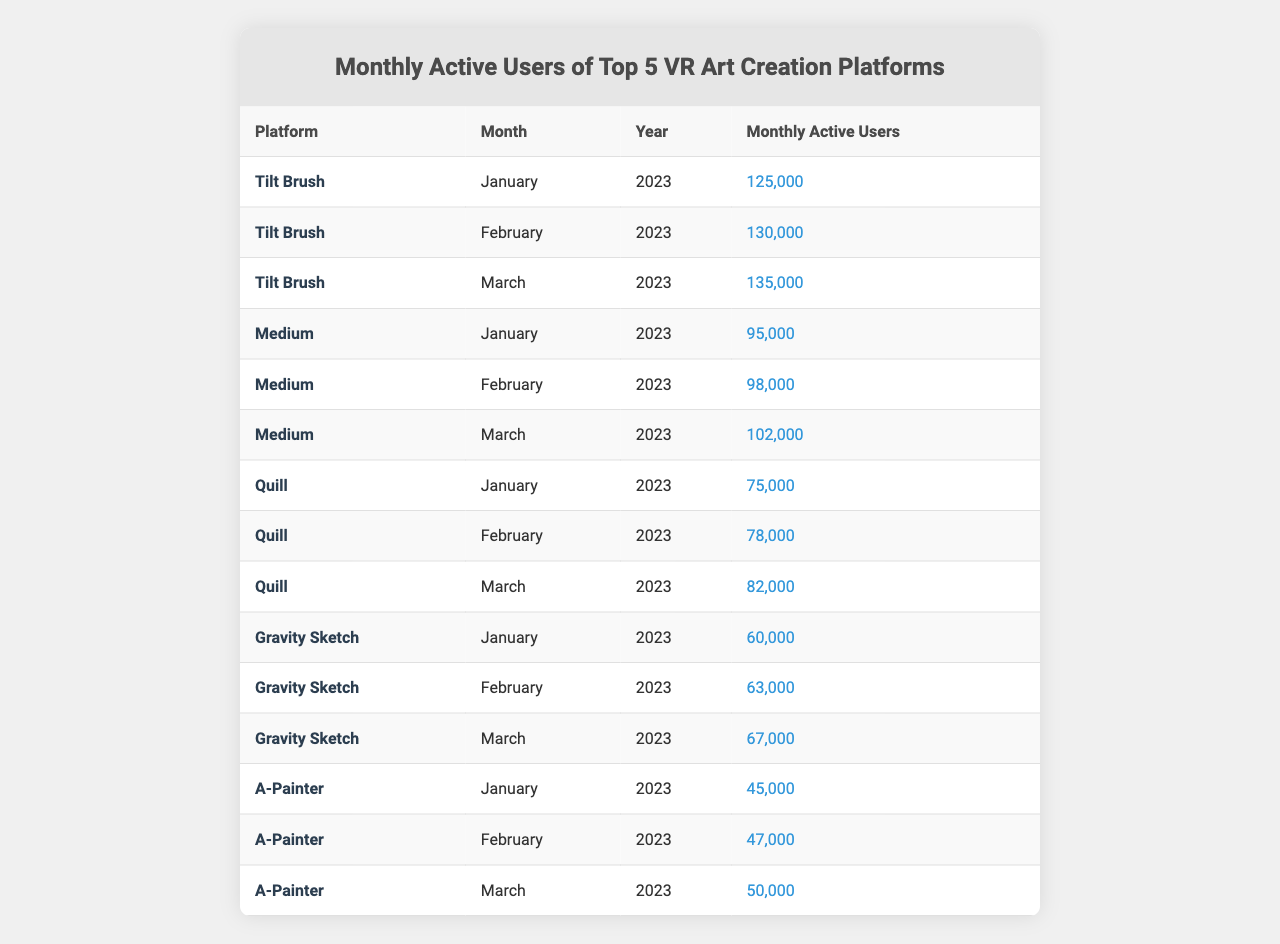What's the platform with the highest number of monthly active users in March 2023? In March 2023, the monthly active users for each platform are: Tilt Brush (135,000), Medium (102,000), Quill (82,000), Gravity Sketch (67,000), and A-Painter (50,000). The highest is Tilt Brush with 135,000 users.
Answer: Tilt Brush What was the percentage increase in monthly active users for A-Painter from January to March 2023? The number of monthly active users for A-Painter in January is 45,000 and in March is 50,000. The increase is (50,000 - 45,000) = 5,000. The percentage increase is (5,000 / 45,000) * 100 = approximately 11.11%.
Answer: 11.11% Did Medium have more monthly active users than Gravity Sketch in February 2023? In February 2023, Medium had 98,000 users and Gravity Sketch had 63,000 users. Since 98,000 is greater than 63,000, Medium did have more users.
Answer: Yes Which platform saw the largest increase in monthly active users from January to February 2023? The increases from January to February for each platform are: Tilt Brush (5,000), Medium (3,000), Quill (3,000), Gravity Sketch (3,000), and A-Painter (2,000). Tilt Brush had the largest increase of 5,000 users.
Answer: Tilt Brush What is the total number of monthly active users across all platforms for March 2023? The monthly active users in March 2023 are: Tilt Brush (135,000), Medium (102,000), Quill (82,000), Gravity Sketch (67,000), and A-Painter (50,000). Adding these gives: 135,000 + 102,000 + 82,000 + 67,000 + 50,000 = 436,000.
Answer: 436,000 Which platform had the lowest number of monthly active users in January 2023? In January 2023, the monthly active users for the platforms were: Tilt Brush (125,000), Medium (95,000), Quill (75,000), Gravity Sketch (60,000), and A-Painter (45,000). A-Painter had the lowest with 45,000 users.
Answer: A-Painter What is the average monthly active users for Quill over the three months? The monthly active users for Quill are: January (75,000), February (78,000), and March (82,000). Summing these gives: 75,000 + 78,000 + 82,000 = 235,000. The average is 235,000 / 3 = 78,333.33, which can be rounded to 78,333.
Answer: 78,333 Was there a decrease in monthly active users for any platform from February to March 2023? The changes from February to March for each platform are: Tilt Brush (increase), Medium (increase), Quill (increase), Gravity Sketch (increase), and A-Painter (increase). Since all platforms increased their users, there was no decrease.
Answer: No 